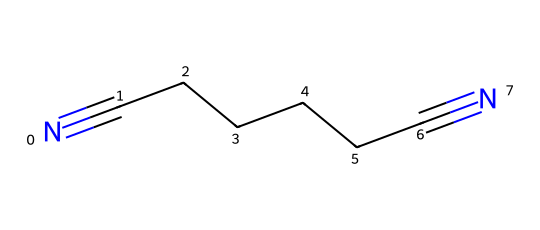What is the chemical name of this compound? By analyzing the structure represented by the SMILES notation, the compound consists of a straight chain of six carbon atoms flanked by two nitrile groups (CN), which signifies that the compound is called adiponitrile.
Answer: adiponitrile How many carbon atoms are present in this structure? The SMILES notation indicates a straight chain of six carbon atoms as seen between the nitrile groups. Each "C" in the notation contributes one carbon atom.
Answer: 6 What is the total number of nitrogen atoms in this molecule? The SMILES representation includes two nitrile groups, where each group contains one nitrogen atom. Thus, there are a total of two nitrogen atoms.
Answer: 2 What type of functional groups are present in adiponitrile? The compound contains nitrile functional groups characterized by the presence of carbon triple-bonded to nitrogen (C≡N), which are evident from the notation N#C.
Answer: nitrile What is the degree of unsaturation in adiponitrile? The two nitrile groups contribute significantly to the degree of unsaturation. Each nitrile adds a contribution of one to the unsaturation count. With the six carbon chain, the overall degree of unsaturation is four.
Answer: 4 Is adiponitrile a saturated or unsaturated compound? Since the structure contains multiple double/triple bonds (the C≡N bonds), it is classified as unsaturated due to the presence of these instability-causing bonds that resist saturation by hydrogen.
Answer: unsaturated 